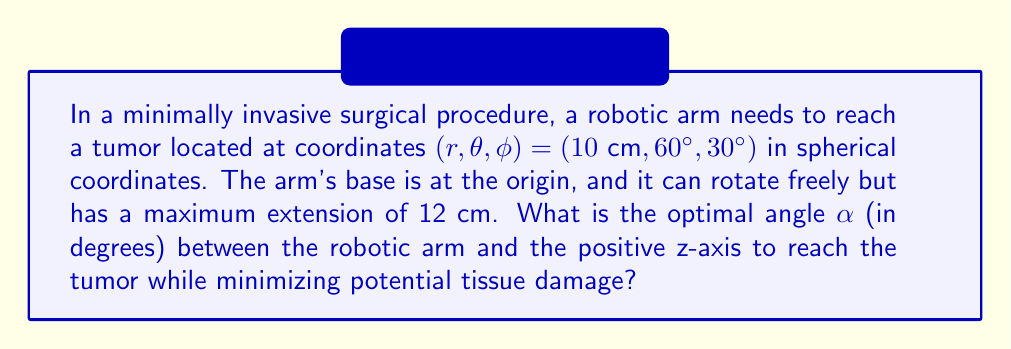Help me with this question. To solve this problem, we'll follow these steps:

1) In spherical coordinates, $\theta$ represents the azimuthal angle in the x-y plane from the x-axis (0° to 360°), and $\phi$ represents the polar angle from the z-axis (0° to 180°).

2) The angle we're looking for, $\alpha$, is actually the same as $\phi$ in spherical coordinates.

3) However, we need to verify if the robotic arm can reach the tumor directly:

   The distance to the tumor is given by $r = 10\text{ cm}$, which is less than the maximum extension of 12 cm.

4) Since the arm can reach the tumor directly, the optimal angle will be the one that reaches the tumor with the shortest path, which is a straight line.

5) Therefore, the optimal angle $\alpha$ is equal to the given $\phi$ coordinate of the tumor.

$$\alpha = \phi = 30°$$

This angle minimizes the path through the tissue, thereby reducing potential damage.
Answer: $30°$ 